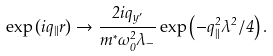<formula> <loc_0><loc_0><loc_500><loc_500>\exp \left ( i { q } _ { \| } { r } \right ) \to \frac { 2 i q _ { y ^ { \prime } } } { m ^ { * } \omega _ { 0 } ^ { 2 } \lambda _ { - } } \exp \left ( - q _ { \| } ^ { 2 } \lambda ^ { 2 } / 4 \right ) .</formula> 